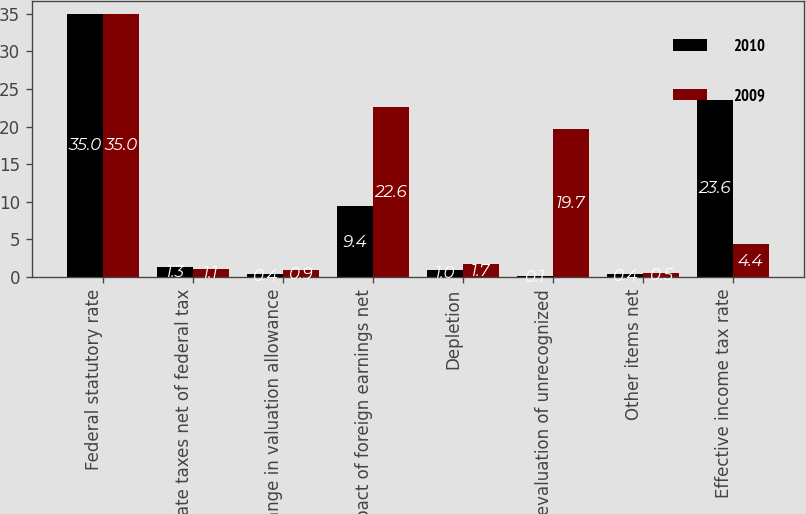<chart> <loc_0><loc_0><loc_500><loc_500><stacked_bar_chart><ecel><fcel>Federal statutory rate<fcel>State taxes net of federal tax<fcel>Change in valuation allowance<fcel>Impact of foreign earnings net<fcel>Depletion<fcel>Revaluation of unrecognized<fcel>Other items net<fcel>Effective income tax rate<nl><fcel>2010<fcel>35<fcel>1.3<fcel>0.4<fcel>9.4<fcel>1<fcel>0.1<fcel>0.4<fcel>23.6<nl><fcel>2009<fcel>35<fcel>1.1<fcel>0.9<fcel>22.6<fcel>1.7<fcel>19.7<fcel>0.5<fcel>4.4<nl></chart> 